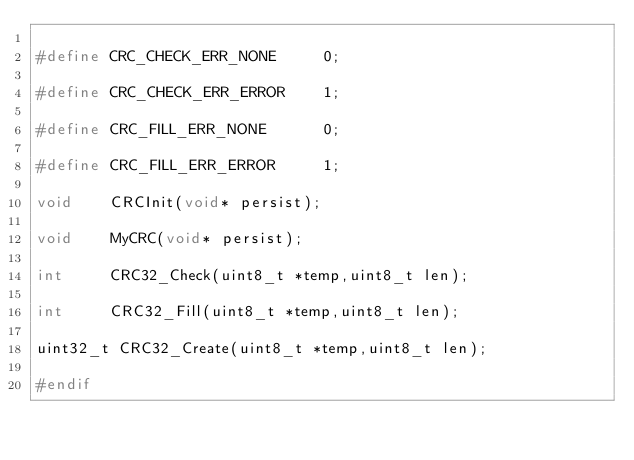Convert code to text. <code><loc_0><loc_0><loc_500><loc_500><_C_>
#define CRC_CHECK_ERR_NONE     0;

#define CRC_CHECK_ERR_ERROR    1;

#define CRC_FILL_ERR_NONE      0;

#define CRC_FILL_ERR_ERROR     1;

void    CRCInit(void* persist);

void    MyCRC(void* persist);

int 		CRC32_Check(uint8_t *temp,uint8_t len);

int 		CRC32_Fill(uint8_t *temp,uint8_t len);

uint32_t CRC32_Create(uint8_t *temp,uint8_t len);

#endif
</code> 